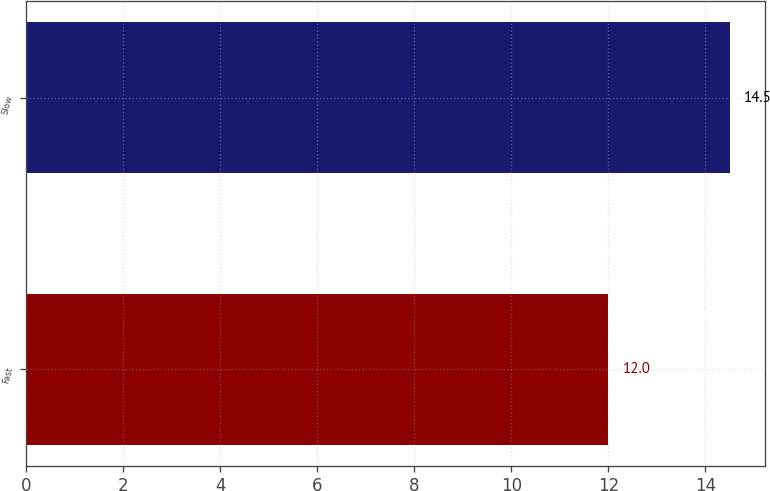Convert chart. <chart><loc_0><loc_0><loc_500><loc_500><bar_chart><fcel>Fast<fcel>Slow<nl><fcel>12<fcel>14.5<nl></chart> 